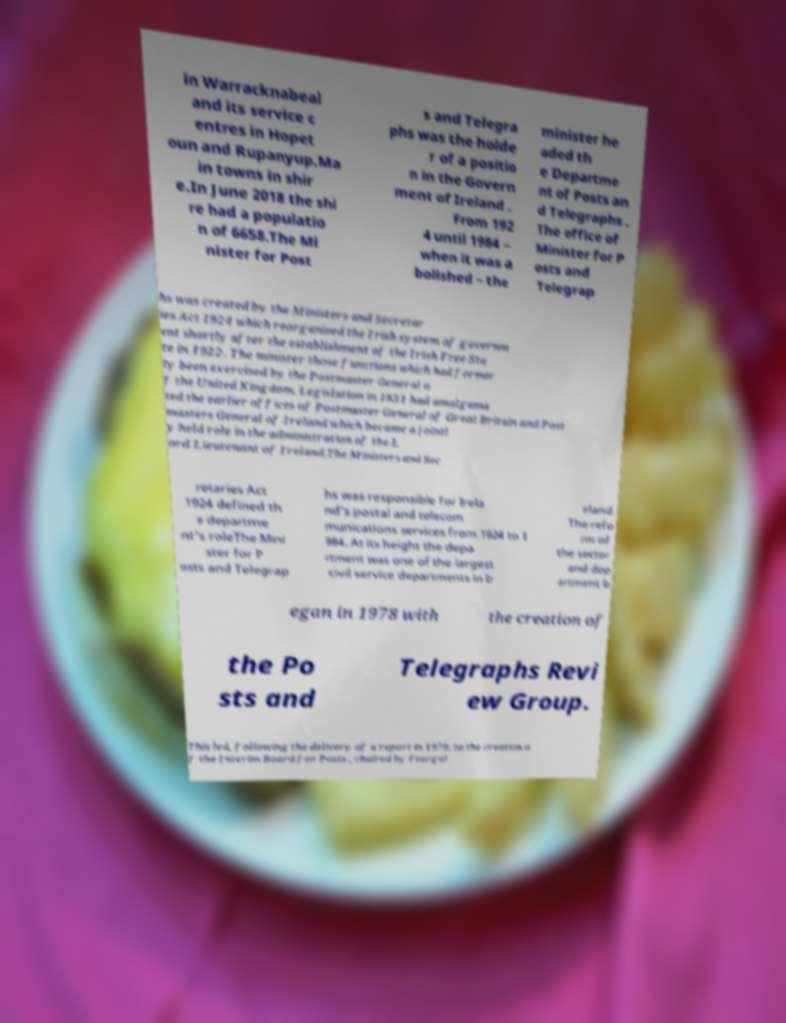Could you extract and type out the text from this image? in Warracknabeal and its service c entres in Hopet oun and Rupanyup.Ma in towns in shir e.In June 2018 the shi re had a populatio n of 6658.The Mi nister for Post s and Telegra phs was the holde r of a positio n in the Govern ment of Ireland . From 192 4 until 1984 – when it was a bolished – the minister he aded th e Departme nt of Posts an d Telegraphs . The office of Minister for P osts and Telegrap hs was created by the Ministers and Secretar ies Act 1924 which reorganised the Irish system of governm ent shortly after the establishment of the Irish Free Sta te in 1922. The minister those functions which had former ly been exercised by the Postmaster General o f the United Kingdom. Legislation in 1831 had amalgama ted the earlier offices of Postmaster General of Great Britain and Post masters General of Ireland which became a jointl y held role in the administration of the L ord Lieutenant of Ireland.The Ministers and Sec retaries Act 1924 defined th e departme nt's roleThe Mini ster for P osts and Telegrap hs was responsible for Irela nd's postal and telecom munications services from 1924 to 1 984. At its height the depa rtment was one of the largest civil service departments in Ir eland. The refo rm of the sector and dep artment b egan in 1978 with the creation of the Po sts and Telegraphs Revi ew Group. This led, following the delivery of a report in 1979, to the creation o f the Interim Board for Posts , chaired by Feargal 